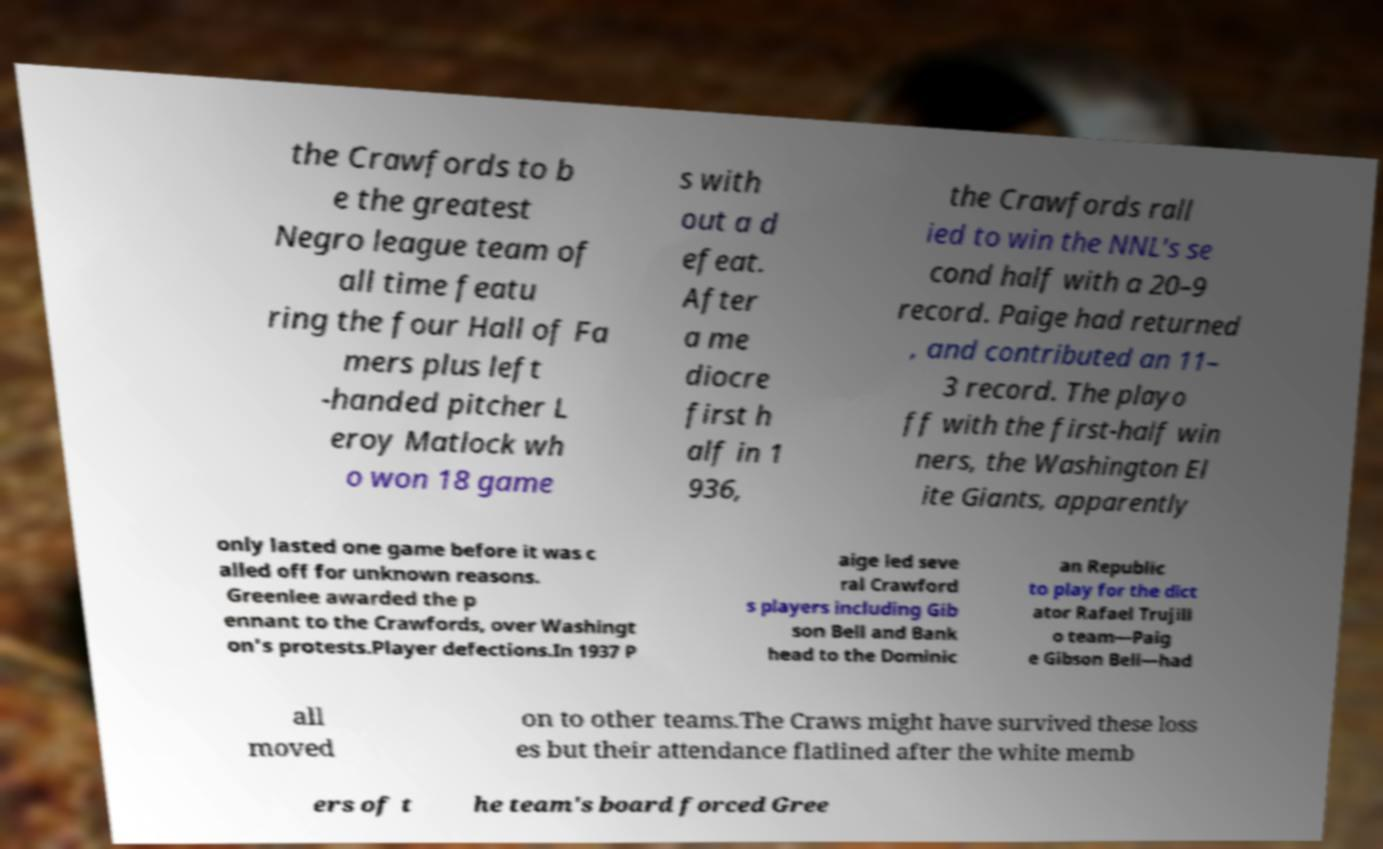Can you accurately transcribe the text from the provided image for me? the Crawfords to b e the greatest Negro league team of all time featu ring the four Hall of Fa mers plus left -handed pitcher L eroy Matlock wh o won 18 game s with out a d efeat. After a me diocre first h alf in 1 936, the Crawfords rall ied to win the NNL's se cond half with a 20–9 record. Paige had returned , and contributed an 11– 3 record. The playo ff with the first-half win ners, the Washington El ite Giants, apparently only lasted one game before it was c alled off for unknown reasons. Greenlee awarded the p ennant to the Crawfords, over Washingt on's protests.Player defections.In 1937 P aige led seve ral Crawford s players including Gib son Bell and Bank head to the Dominic an Republic to play for the dict ator Rafael Trujill o team—Paig e Gibson Bell—had all moved on to other teams.The Craws might have survived these loss es but their attendance flatlined after the white memb ers of t he team's board forced Gree 